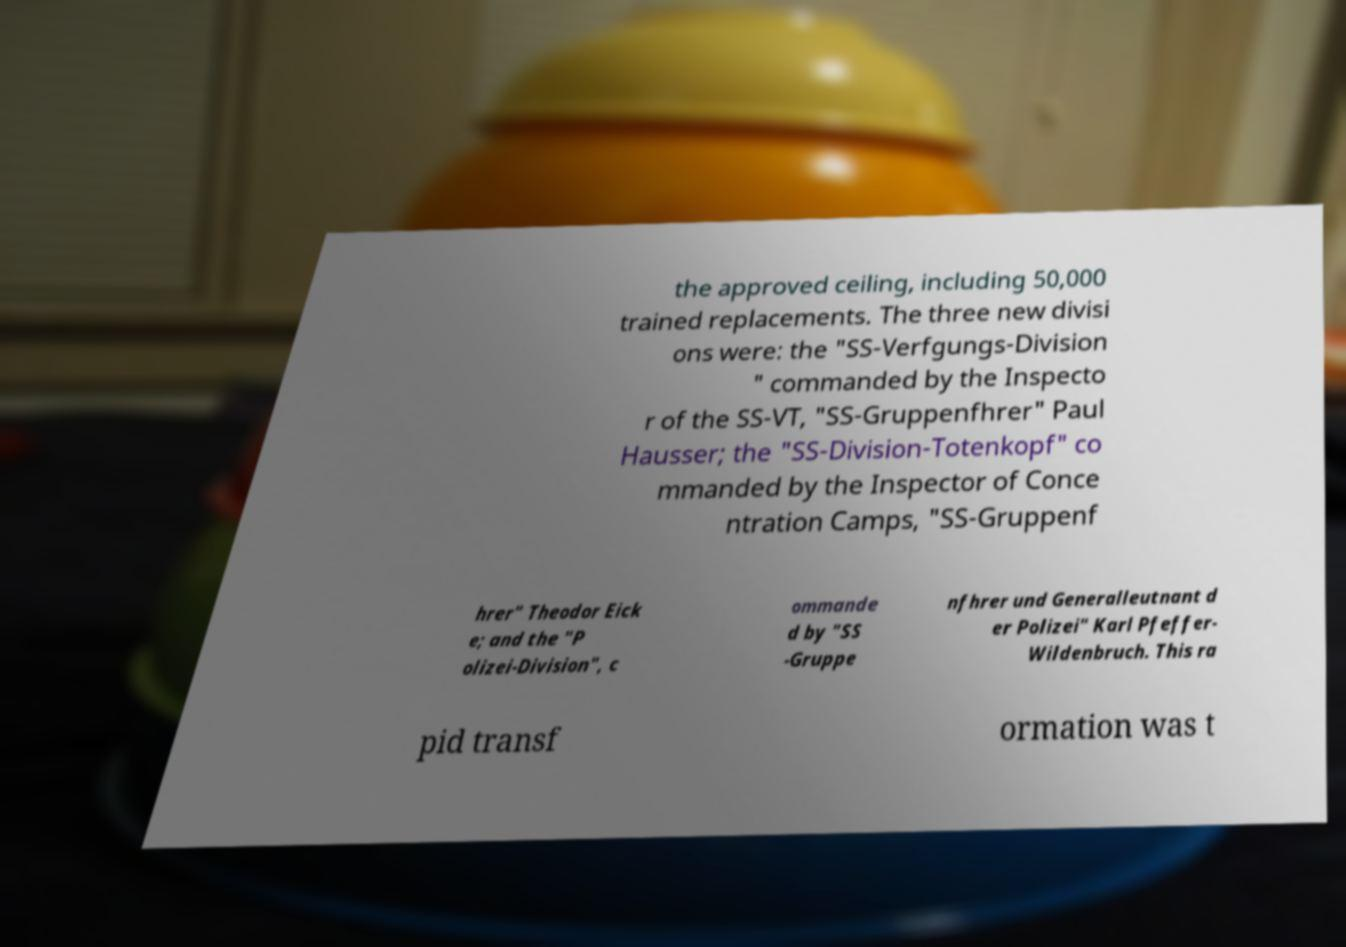Please identify and transcribe the text found in this image. the approved ceiling, including 50,000 trained replacements. The three new divisi ons were: the "SS-Verfgungs-Division " commanded by the Inspecto r of the SS-VT, "SS-Gruppenfhrer" Paul Hausser; the "SS-Division-Totenkopf" co mmanded by the Inspector of Conce ntration Camps, "SS-Gruppenf hrer" Theodor Eick e; and the "P olizei-Division", c ommande d by "SS -Gruppe nfhrer und Generalleutnant d er Polizei" Karl Pfeffer- Wildenbruch. This ra pid transf ormation was t 